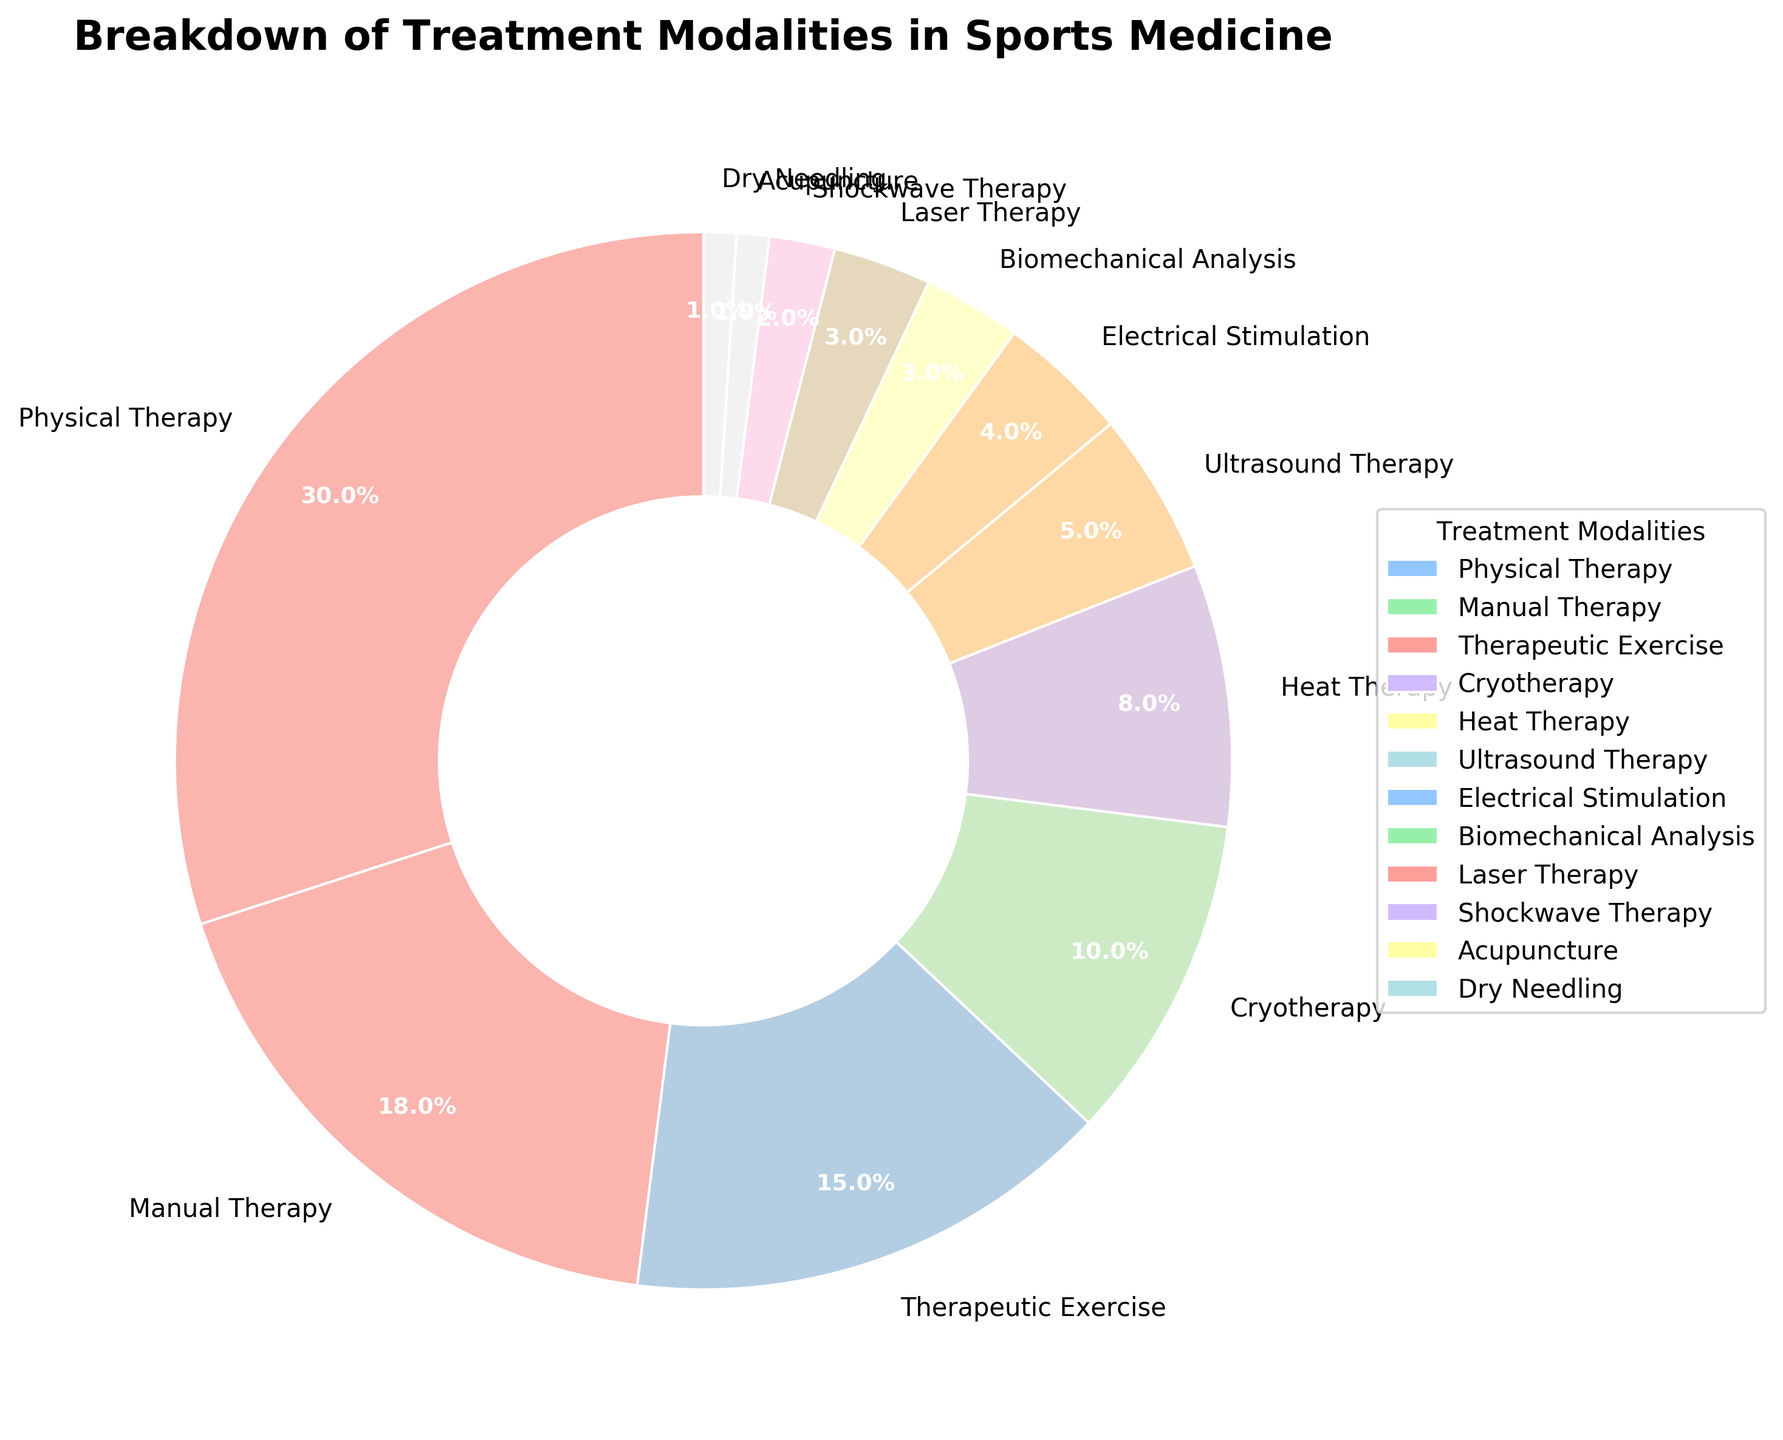What's the most commonly used treatment modality? The pie chart clearly shows that Physical Therapy occupies the largest segment.
Answer: Physical Therapy What's the least commonly used treatment modality? The smallest segment in the pie chart corresponds to Acupuncture and Dry Needling.
Answer: Acupuncture and Dry Needling What is the combined percentage of Cryotherapy and Heat Therapy? Cryotherapy accounts for 10% and Heat Therapy for 8%. Together, they make 10% + 8% = 18%.
Answer: 18% Which treatment modalities make up exactly half of the chart? Physical Therapy, Manual Therapy, and Therapeutic Exercise are 30%, 18%, and 15%, respectively. Adding them gives 30% + 18% + 15% = 63%. But, Cryotherapy and Heat Therapy together make 18%, adding up to the previous total leads to 63% + 18% = 81%. Therefore, Physical Therapy (30%), Manual Therapy (18%), Therapeutic Exercise (15%), Cryotherapy (10%) and Heat Therapy (8%) combined exceed half the chart, but no combination of two categories alone sums to exactly 50%. Hence, there is no exact combination equaling 50%.
Answer: None How does the percentage for Therapeutic Exercise compare to Electrical Stimulation? Therapeutic Exercise is 15%, while Electrical Stimulation is 4%. Therefore, Therapeutic Exercise is significantly higher than Electrical Stimulation.
Answer: Therapeutic Exercise is significantly higher What are the third and fourth most used treatment modalities? The top four entries are Physical Therapy (30%), Manual Therapy (18%), Therapeutic Exercise (15%), and Cryotherapy (10%). The third most used is Therapeutic Exercise, and the fourth is Cryotherapy.
Answer: Therapeutic Exercise and Cryotherapy What's the difference in percentage between the top two treatment modalities? The top two treatments are Physical Therapy (30%) and Manual Therapy (18%). The difference is 30% - 18% = 12%.
Answer: 12% How many treatment modalities make up less than 5% each? The pie chart segments for Ultrasound Therapy (5%), Electrical Stimulation (4%), Biomechanical Analysis (3%), Laser Therapy (3%), Shockwave Therapy (2%), Acupuncture (1%), and Dry Needling (1%) are each less than 5%. So there are 7 treatment modalities making up less than 5% each.
Answer: 7 If you sum up the two least common modalities, what percentage do you get? The least common modalities are Acupuncture (1%) and Dry Needling (1%). Adding these gives 1% + 1% = 2%.
Answer: 2% Which treatment modality has a higher percentage, Biomechanical Analysis or Laser Therapy? Both Biomechanical Analysis and Laser Therapy each have a percentage of 3%. They are equal.
Answer: Equal 